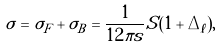<formula> <loc_0><loc_0><loc_500><loc_500>\sigma = \sigma _ { F } + \sigma _ { B } = \frac { 1 } { 1 2 \pi s } S ( 1 + \Delta _ { \ell } ) ,</formula> 